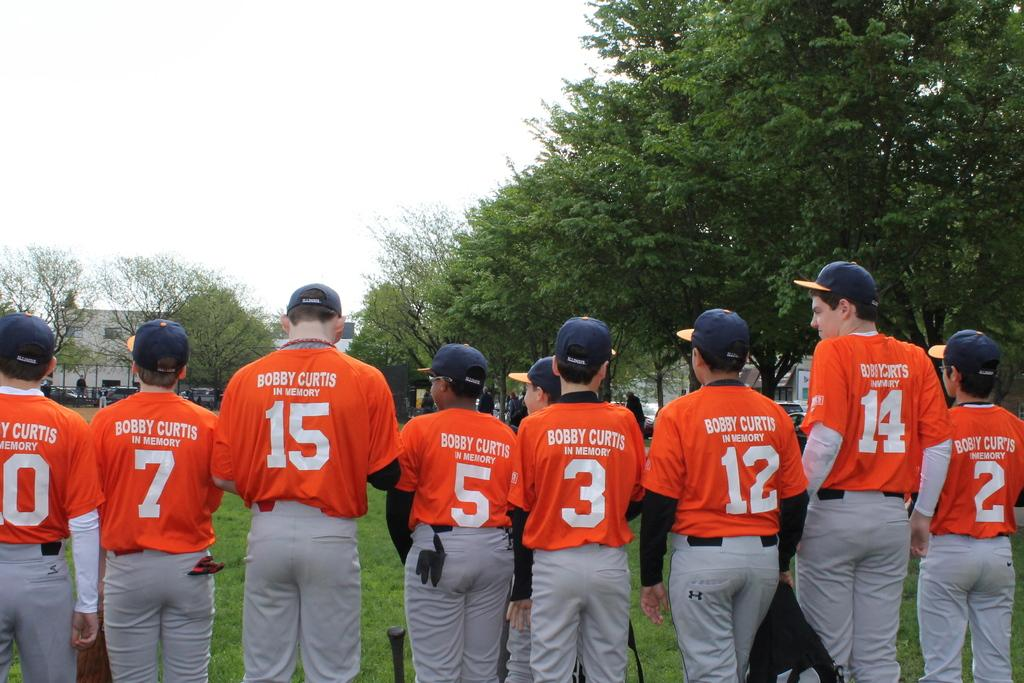<image>
Write a terse but informative summary of the picture. many players with one wearing the number 5 